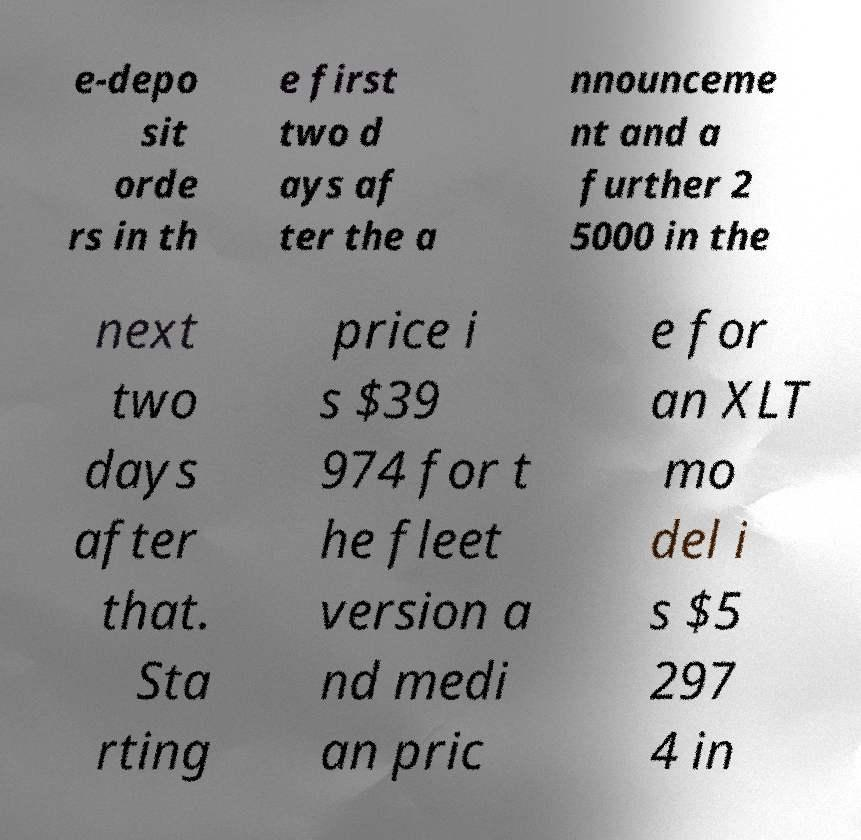Could you extract and type out the text from this image? e-depo sit orde rs in th e first two d ays af ter the a nnounceme nt and a further 2 5000 in the next two days after that. Sta rting price i s $39 974 for t he fleet version a nd medi an pric e for an XLT mo del i s $5 297 4 in 